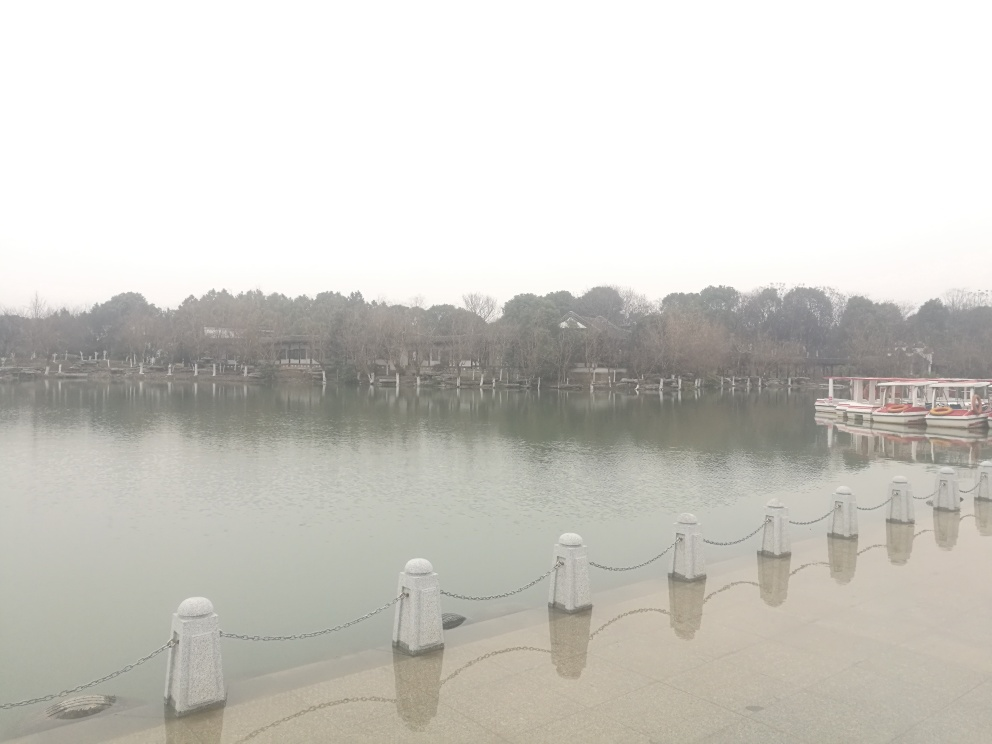Can you provide some insights into what the area might be used for? The presence of moored boats suggests this area is used for recreational boating or possibly as a small marina. The open space and the arrangement of seating areas indicate it could also be a place where people come to relax by the water or enjoy leisurely activities. 